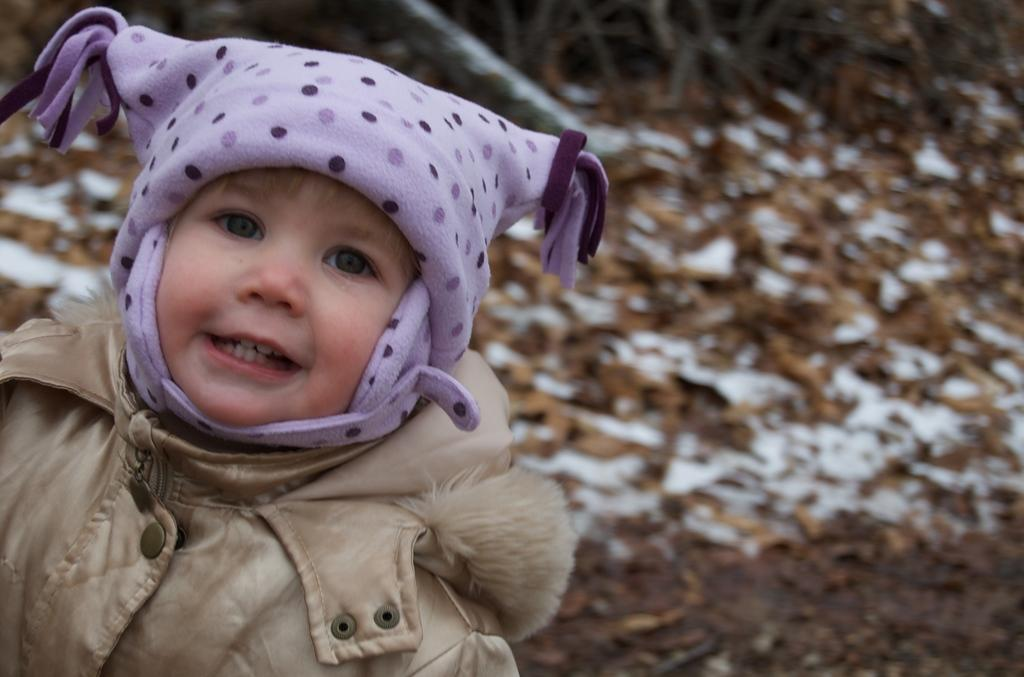What is the main subject of the image? The main subject of the image is a kid. What is the kid wearing in the image? The kid is wearing clothes and a cap. Can you describe the background of the image? The background of the image is blurred. What type of cream can be seen being applied to the dirt in the image? There is no cream or dirt present in the image; it features a kid wearing clothes and a cap, with a blurred background. 